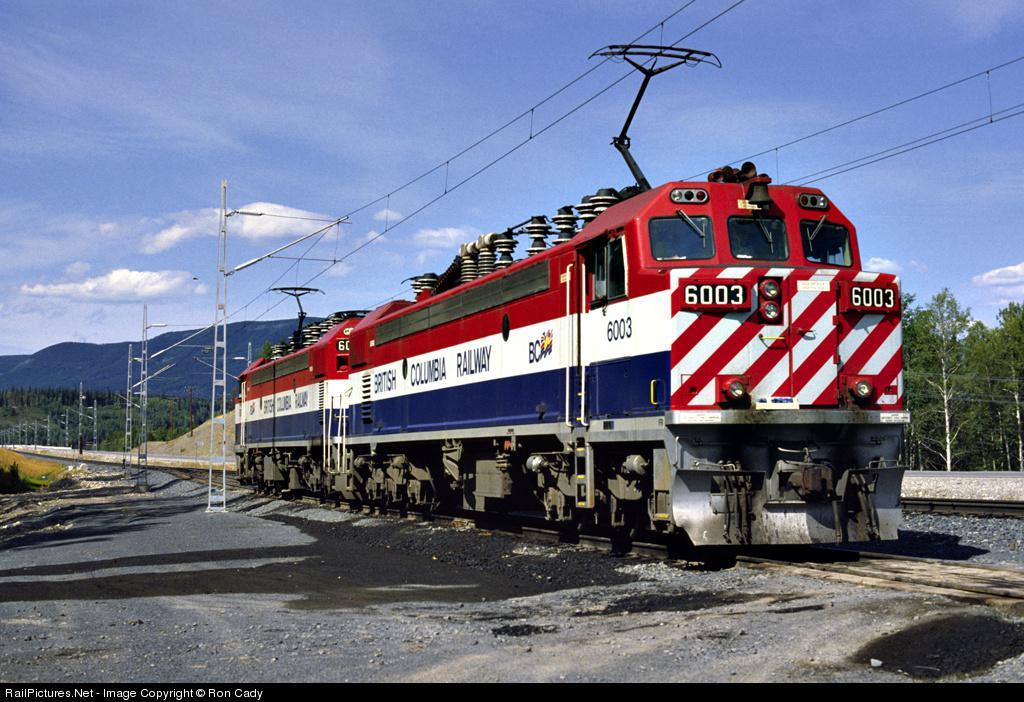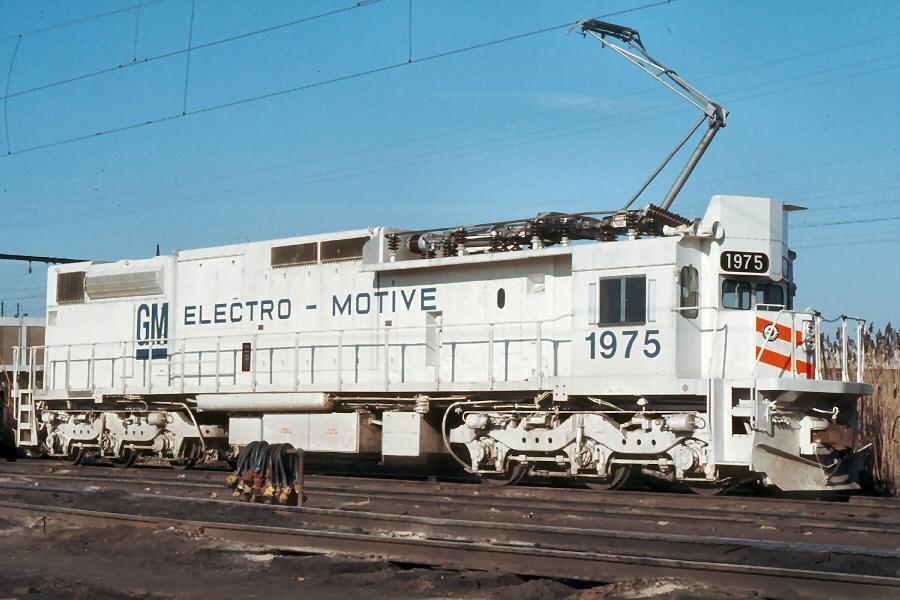The first image is the image on the left, the second image is the image on the right. For the images displayed, is the sentence "Each image shows a red-topped train with white and blue stripes running horizontally along the side." factually correct? Answer yes or no. No. The first image is the image on the left, the second image is the image on the right. Assess this claim about the two images: "Both trains are red, white, and blue.". Correct or not? Answer yes or no. No. 